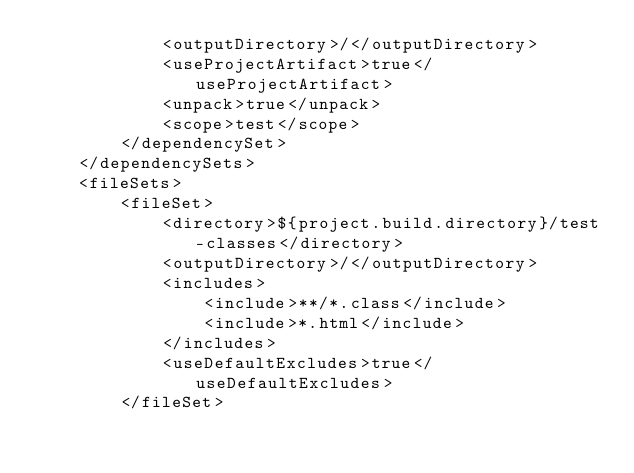Convert code to text. <code><loc_0><loc_0><loc_500><loc_500><_XML_>            <outputDirectory>/</outputDirectory>
            <useProjectArtifact>true</useProjectArtifact>
            <unpack>true</unpack>
            <scope>test</scope>
        </dependencySet>
    </dependencySets>
    <fileSets>
        <fileSet>
            <directory>${project.build.directory}/test-classes</directory>
            <outputDirectory>/</outputDirectory>
            <includes>
                <include>**/*.class</include>
                <include>*.html</include>
            </includes>
            <useDefaultExcludes>true</useDefaultExcludes>
        </fileSet></code> 